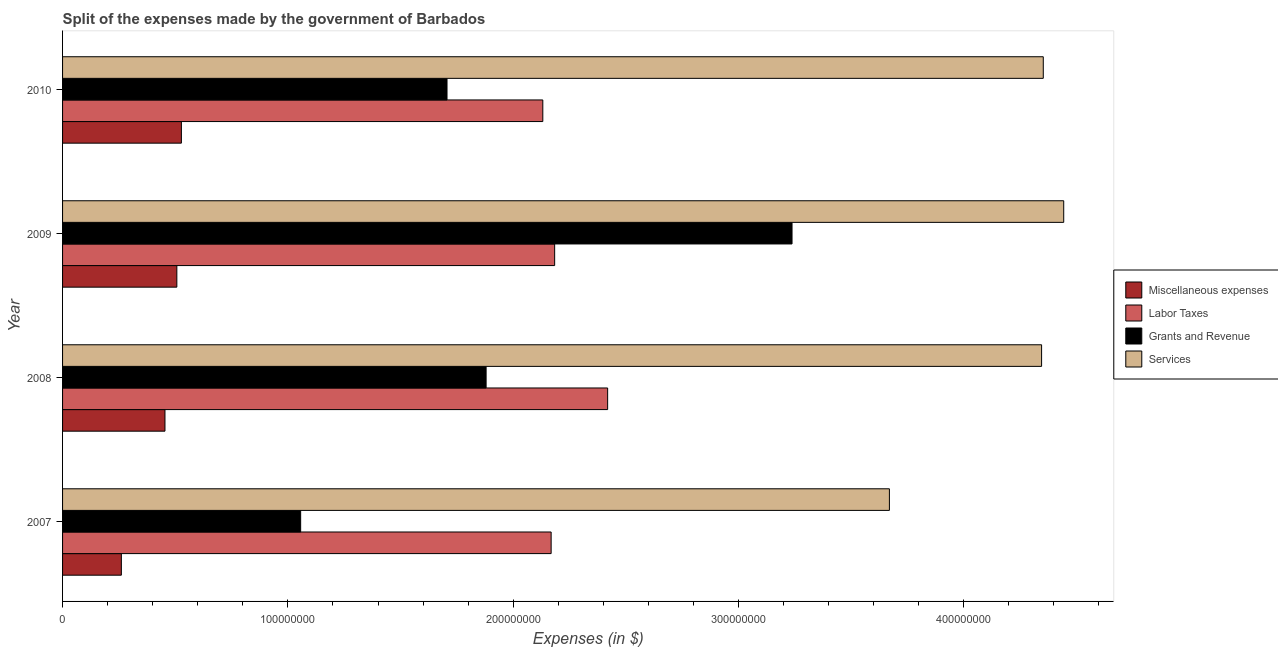How many different coloured bars are there?
Your answer should be compact. 4. How many groups of bars are there?
Your answer should be compact. 4. Are the number of bars per tick equal to the number of legend labels?
Make the answer very short. Yes. Are the number of bars on each tick of the Y-axis equal?
Give a very brief answer. Yes. How many bars are there on the 3rd tick from the top?
Offer a terse response. 4. In how many cases, is the number of bars for a given year not equal to the number of legend labels?
Provide a short and direct response. 0. What is the amount spent on services in 2009?
Your answer should be very brief. 4.44e+08. Across all years, what is the maximum amount spent on miscellaneous expenses?
Your answer should be very brief. 5.27e+07. Across all years, what is the minimum amount spent on services?
Give a very brief answer. 3.67e+08. In which year was the amount spent on labor taxes minimum?
Keep it short and to the point. 2010. What is the total amount spent on labor taxes in the graph?
Keep it short and to the point. 8.90e+08. What is the difference between the amount spent on services in 2007 and that in 2008?
Provide a succinct answer. -6.75e+07. What is the difference between the amount spent on miscellaneous expenses in 2010 and the amount spent on labor taxes in 2008?
Offer a very short reply. -1.89e+08. What is the average amount spent on miscellaneous expenses per year?
Your response must be concise. 4.38e+07. In the year 2009, what is the difference between the amount spent on miscellaneous expenses and amount spent on services?
Give a very brief answer. -3.94e+08. In how many years, is the amount spent on miscellaneous expenses greater than 260000000 $?
Provide a succinct answer. 0. What is the ratio of the amount spent on miscellaneous expenses in 2008 to that in 2010?
Your response must be concise. 0.86. Is the amount spent on grants and revenue in 2007 less than that in 2010?
Provide a succinct answer. Yes. What is the difference between the highest and the second highest amount spent on grants and revenue?
Provide a succinct answer. 1.36e+08. What is the difference between the highest and the lowest amount spent on services?
Your answer should be very brief. 7.74e+07. What does the 4th bar from the top in 2009 represents?
Offer a terse response. Miscellaneous expenses. What does the 2nd bar from the bottom in 2007 represents?
Give a very brief answer. Labor Taxes. Is it the case that in every year, the sum of the amount spent on miscellaneous expenses and amount spent on labor taxes is greater than the amount spent on grants and revenue?
Offer a very short reply. No. How many years are there in the graph?
Make the answer very short. 4. Are the values on the major ticks of X-axis written in scientific E-notation?
Your answer should be compact. No. Does the graph contain any zero values?
Your answer should be very brief. No. Where does the legend appear in the graph?
Ensure brevity in your answer.  Center right. How many legend labels are there?
Your response must be concise. 4. How are the legend labels stacked?
Make the answer very short. Vertical. What is the title of the graph?
Give a very brief answer. Split of the expenses made by the government of Barbados. What is the label or title of the X-axis?
Provide a succinct answer. Expenses (in $). What is the Expenses (in $) of Miscellaneous expenses in 2007?
Your answer should be compact. 2.61e+07. What is the Expenses (in $) of Labor Taxes in 2007?
Give a very brief answer. 2.17e+08. What is the Expenses (in $) of Grants and Revenue in 2007?
Keep it short and to the point. 1.06e+08. What is the Expenses (in $) of Services in 2007?
Your answer should be very brief. 3.67e+08. What is the Expenses (in $) of Miscellaneous expenses in 2008?
Ensure brevity in your answer.  4.55e+07. What is the Expenses (in $) of Labor Taxes in 2008?
Provide a succinct answer. 2.42e+08. What is the Expenses (in $) in Grants and Revenue in 2008?
Ensure brevity in your answer.  1.88e+08. What is the Expenses (in $) of Services in 2008?
Make the answer very short. 4.35e+08. What is the Expenses (in $) in Miscellaneous expenses in 2009?
Give a very brief answer. 5.07e+07. What is the Expenses (in $) of Labor Taxes in 2009?
Your answer should be compact. 2.18e+08. What is the Expenses (in $) in Grants and Revenue in 2009?
Your response must be concise. 3.24e+08. What is the Expenses (in $) in Services in 2009?
Offer a terse response. 4.44e+08. What is the Expenses (in $) in Miscellaneous expenses in 2010?
Your answer should be compact. 5.27e+07. What is the Expenses (in $) of Labor Taxes in 2010?
Your response must be concise. 2.13e+08. What is the Expenses (in $) in Grants and Revenue in 2010?
Your answer should be compact. 1.71e+08. What is the Expenses (in $) of Services in 2010?
Give a very brief answer. 4.35e+08. Across all years, what is the maximum Expenses (in $) in Miscellaneous expenses?
Keep it short and to the point. 5.27e+07. Across all years, what is the maximum Expenses (in $) in Labor Taxes?
Offer a terse response. 2.42e+08. Across all years, what is the maximum Expenses (in $) of Grants and Revenue?
Offer a terse response. 3.24e+08. Across all years, what is the maximum Expenses (in $) of Services?
Your answer should be compact. 4.44e+08. Across all years, what is the minimum Expenses (in $) in Miscellaneous expenses?
Your answer should be very brief. 2.61e+07. Across all years, what is the minimum Expenses (in $) in Labor Taxes?
Your answer should be very brief. 2.13e+08. Across all years, what is the minimum Expenses (in $) of Grants and Revenue?
Give a very brief answer. 1.06e+08. Across all years, what is the minimum Expenses (in $) in Services?
Your answer should be compact. 3.67e+08. What is the total Expenses (in $) of Miscellaneous expenses in the graph?
Your response must be concise. 1.75e+08. What is the total Expenses (in $) in Labor Taxes in the graph?
Ensure brevity in your answer.  8.90e+08. What is the total Expenses (in $) of Grants and Revenue in the graph?
Offer a terse response. 7.88e+08. What is the total Expenses (in $) in Services in the graph?
Keep it short and to the point. 1.68e+09. What is the difference between the Expenses (in $) in Miscellaneous expenses in 2007 and that in 2008?
Provide a short and direct response. -1.94e+07. What is the difference between the Expenses (in $) in Labor Taxes in 2007 and that in 2008?
Ensure brevity in your answer.  -2.51e+07. What is the difference between the Expenses (in $) of Grants and Revenue in 2007 and that in 2008?
Your response must be concise. -8.23e+07. What is the difference between the Expenses (in $) of Services in 2007 and that in 2008?
Your response must be concise. -6.75e+07. What is the difference between the Expenses (in $) of Miscellaneous expenses in 2007 and that in 2009?
Provide a short and direct response. -2.46e+07. What is the difference between the Expenses (in $) in Labor Taxes in 2007 and that in 2009?
Provide a succinct answer. -1.56e+06. What is the difference between the Expenses (in $) of Grants and Revenue in 2007 and that in 2009?
Provide a short and direct response. -2.18e+08. What is the difference between the Expenses (in $) in Services in 2007 and that in 2009?
Ensure brevity in your answer.  -7.74e+07. What is the difference between the Expenses (in $) in Miscellaneous expenses in 2007 and that in 2010?
Your response must be concise. -2.66e+07. What is the difference between the Expenses (in $) in Labor Taxes in 2007 and that in 2010?
Your answer should be compact. 3.69e+06. What is the difference between the Expenses (in $) in Grants and Revenue in 2007 and that in 2010?
Make the answer very short. -6.50e+07. What is the difference between the Expenses (in $) of Services in 2007 and that in 2010?
Your response must be concise. -6.83e+07. What is the difference between the Expenses (in $) in Miscellaneous expenses in 2008 and that in 2009?
Make the answer very short. -5.27e+06. What is the difference between the Expenses (in $) of Labor Taxes in 2008 and that in 2009?
Offer a terse response. 2.35e+07. What is the difference between the Expenses (in $) in Grants and Revenue in 2008 and that in 2009?
Your answer should be compact. -1.36e+08. What is the difference between the Expenses (in $) in Services in 2008 and that in 2009?
Your answer should be very brief. -9.82e+06. What is the difference between the Expenses (in $) of Miscellaneous expenses in 2008 and that in 2010?
Make the answer very short. -7.29e+06. What is the difference between the Expenses (in $) in Labor Taxes in 2008 and that in 2010?
Keep it short and to the point. 2.88e+07. What is the difference between the Expenses (in $) of Grants and Revenue in 2008 and that in 2010?
Your answer should be compact. 1.73e+07. What is the difference between the Expenses (in $) of Services in 2008 and that in 2010?
Provide a short and direct response. -7.51e+05. What is the difference between the Expenses (in $) of Miscellaneous expenses in 2009 and that in 2010?
Keep it short and to the point. -2.02e+06. What is the difference between the Expenses (in $) of Labor Taxes in 2009 and that in 2010?
Provide a short and direct response. 5.25e+06. What is the difference between the Expenses (in $) of Grants and Revenue in 2009 and that in 2010?
Your answer should be compact. 1.53e+08. What is the difference between the Expenses (in $) in Services in 2009 and that in 2010?
Provide a succinct answer. 9.07e+06. What is the difference between the Expenses (in $) in Miscellaneous expenses in 2007 and the Expenses (in $) in Labor Taxes in 2008?
Offer a very short reply. -2.16e+08. What is the difference between the Expenses (in $) of Miscellaneous expenses in 2007 and the Expenses (in $) of Grants and Revenue in 2008?
Give a very brief answer. -1.62e+08. What is the difference between the Expenses (in $) of Miscellaneous expenses in 2007 and the Expenses (in $) of Services in 2008?
Offer a terse response. -4.08e+08. What is the difference between the Expenses (in $) in Labor Taxes in 2007 and the Expenses (in $) in Grants and Revenue in 2008?
Provide a short and direct response. 2.89e+07. What is the difference between the Expenses (in $) in Labor Taxes in 2007 and the Expenses (in $) in Services in 2008?
Ensure brevity in your answer.  -2.18e+08. What is the difference between the Expenses (in $) in Grants and Revenue in 2007 and the Expenses (in $) in Services in 2008?
Your answer should be compact. -3.29e+08. What is the difference between the Expenses (in $) in Miscellaneous expenses in 2007 and the Expenses (in $) in Labor Taxes in 2009?
Keep it short and to the point. -1.92e+08. What is the difference between the Expenses (in $) of Miscellaneous expenses in 2007 and the Expenses (in $) of Grants and Revenue in 2009?
Provide a succinct answer. -2.98e+08. What is the difference between the Expenses (in $) of Miscellaneous expenses in 2007 and the Expenses (in $) of Services in 2009?
Your answer should be compact. -4.18e+08. What is the difference between the Expenses (in $) of Labor Taxes in 2007 and the Expenses (in $) of Grants and Revenue in 2009?
Provide a short and direct response. -1.07e+08. What is the difference between the Expenses (in $) of Labor Taxes in 2007 and the Expenses (in $) of Services in 2009?
Your response must be concise. -2.28e+08. What is the difference between the Expenses (in $) in Grants and Revenue in 2007 and the Expenses (in $) in Services in 2009?
Ensure brevity in your answer.  -3.39e+08. What is the difference between the Expenses (in $) in Miscellaneous expenses in 2007 and the Expenses (in $) in Labor Taxes in 2010?
Make the answer very short. -1.87e+08. What is the difference between the Expenses (in $) of Miscellaneous expenses in 2007 and the Expenses (in $) of Grants and Revenue in 2010?
Offer a very short reply. -1.45e+08. What is the difference between the Expenses (in $) in Miscellaneous expenses in 2007 and the Expenses (in $) in Services in 2010?
Offer a very short reply. -4.09e+08. What is the difference between the Expenses (in $) of Labor Taxes in 2007 and the Expenses (in $) of Grants and Revenue in 2010?
Make the answer very short. 4.62e+07. What is the difference between the Expenses (in $) of Labor Taxes in 2007 and the Expenses (in $) of Services in 2010?
Ensure brevity in your answer.  -2.18e+08. What is the difference between the Expenses (in $) in Grants and Revenue in 2007 and the Expenses (in $) in Services in 2010?
Your answer should be compact. -3.30e+08. What is the difference between the Expenses (in $) in Miscellaneous expenses in 2008 and the Expenses (in $) in Labor Taxes in 2009?
Make the answer very short. -1.73e+08. What is the difference between the Expenses (in $) of Miscellaneous expenses in 2008 and the Expenses (in $) of Grants and Revenue in 2009?
Make the answer very short. -2.78e+08. What is the difference between the Expenses (in $) of Miscellaneous expenses in 2008 and the Expenses (in $) of Services in 2009?
Your answer should be compact. -3.99e+08. What is the difference between the Expenses (in $) in Labor Taxes in 2008 and the Expenses (in $) in Grants and Revenue in 2009?
Provide a short and direct response. -8.18e+07. What is the difference between the Expenses (in $) of Labor Taxes in 2008 and the Expenses (in $) of Services in 2009?
Provide a succinct answer. -2.02e+08. What is the difference between the Expenses (in $) in Grants and Revenue in 2008 and the Expenses (in $) in Services in 2009?
Keep it short and to the point. -2.56e+08. What is the difference between the Expenses (in $) in Miscellaneous expenses in 2008 and the Expenses (in $) in Labor Taxes in 2010?
Make the answer very short. -1.68e+08. What is the difference between the Expenses (in $) in Miscellaneous expenses in 2008 and the Expenses (in $) in Grants and Revenue in 2010?
Offer a very short reply. -1.25e+08. What is the difference between the Expenses (in $) in Miscellaneous expenses in 2008 and the Expenses (in $) in Services in 2010?
Provide a short and direct response. -3.90e+08. What is the difference between the Expenses (in $) in Labor Taxes in 2008 and the Expenses (in $) in Grants and Revenue in 2010?
Ensure brevity in your answer.  7.13e+07. What is the difference between the Expenses (in $) of Labor Taxes in 2008 and the Expenses (in $) of Services in 2010?
Provide a short and direct response. -1.93e+08. What is the difference between the Expenses (in $) in Grants and Revenue in 2008 and the Expenses (in $) in Services in 2010?
Make the answer very short. -2.47e+08. What is the difference between the Expenses (in $) in Miscellaneous expenses in 2009 and the Expenses (in $) in Labor Taxes in 2010?
Make the answer very short. -1.62e+08. What is the difference between the Expenses (in $) of Miscellaneous expenses in 2009 and the Expenses (in $) of Grants and Revenue in 2010?
Provide a succinct answer. -1.20e+08. What is the difference between the Expenses (in $) of Miscellaneous expenses in 2009 and the Expenses (in $) of Services in 2010?
Provide a succinct answer. -3.85e+08. What is the difference between the Expenses (in $) of Labor Taxes in 2009 and the Expenses (in $) of Grants and Revenue in 2010?
Offer a terse response. 4.78e+07. What is the difference between the Expenses (in $) in Labor Taxes in 2009 and the Expenses (in $) in Services in 2010?
Ensure brevity in your answer.  -2.17e+08. What is the difference between the Expenses (in $) of Grants and Revenue in 2009 and the Expenses (in $) of Services in 2010?
Your response must be concise. -1.12e+08. What is the average Expenses (in $) in Miscellaneous expenses per year?
Offer a very short reply. 4.38e+07. What is the average Expenses (in $) in Labor Taxes per year?
Make the answer very short. 2.23e+08. What is the average Expenses (in $) of Grants and Revenue per year?
Provide a succinct answer. 1.97e+08. What is the average Expenses (in $) in Services per year?
Make the answer very short. 4.20e+08. In the year 2007, what is the difference between the Expenses (in $) of Miscellaneous expenses and Expenses (in $) of Labor Taxes?
Your response must be concise. -1.91e+08. In the year 2007, what is the difference between the Expenses (in $) in Miscellaneous expenses and Expenses (in $) in Grants and Revenue?
Your response must be concise. -7.96e+07. In the year 2007, what is the difference between the Expenses (in $) in Miscellaneous expenses and Expenses (in $) in Services?
Keep it short and to the point. -3.41e+08. In the year 2007, what is the difference between the Expenses (in $) in Labor Taxes and Expenses (in $) in Grants and Revenue?
Keep it short and to the point. 1.11e+08. In the year 2007, what is the difference between the Expenses (in $) of Labor Taxes and Expenses (in $) of Services?
Your response must be concise. -1.50e+08. In the year 2007, what is the difference between the Expenses (in $) of Grants and Revenue and Expenses (in $) of Services?
Ensure brevity in your answer.  -2.61e+08. In the year 2008, what is the difference between the Expenses (in $) in Miscellaneous expenses and Expenses (in $) in Labor Taxes?
Keep it short and to the point. -1.96e+08. In the year 2008, what is the difference between the Expenses (in $) in Miscellaneous expenses and Expenses (in $) in Grants and Revenue?
Provide a short and direct response. -1.43e+08. In the year 2008, what is the difference between the Expenses (in $) in Miscellaneous expenses and Expenses (in $) in Services?
Give a very brief answer. -3.89e+08. In the year 2008, what is the difference between the Expenses (in $) of Labor Taxes and Expenses (in $) of Grants and Revenue?
Your answer should be very brief. 5.39e+07. In the year 2008, what is the difference between the Expenses (in $) of Labor Taxes and Expenses (in $) of Services?
Give a very brief answer. -1.93e+08. In the year 2008, what is the difference between the Expenses (in $) of Grants and Revenue and Expenses (in $) of Services?
Ensure brevity in your answer.  -2.47e+08. In the year 2009, what is the difference between the Expenses (in $) in Miscellaneous expenses and Expenses (in $) in Labor Taxes?
Offer a very short reply. -1.68e+08. In the year 2009, what is the difference between the Expenses (in $) of Miscellaneous expenses and Expenses (in $) of Grants and Revenue?
Provide a short and direct response. -2.73e+08. In the year 2009, what is the difference between the Expenses (in $) of Miscellaneous expenses and Expenses (in $) of Services?
Your answer should be compact. -3.94e+08. In the year 2009, what is the difference between the Expenses (in $) in Labor Taxes and Expenses (in $) in Grants and Revenue?
Your answer should be compact. -1.05e+08. In the year 2009, what is the difference between the Expenses (in $) in Labor Taxes and Expenses (in $) in Services?
Offer a very short reply. -2.26e+08. In the year 2009, what is the difference between the Expenses (in $) in Grants and Revenue and Expenses (in $) in Services?
Ensure brevity in your answer.  -1.21e+08. In the year 2010, what is the difference between the Expenses (in $) in Miscellaneous expenses and Expenses (in $) in Labor Taxes?
Provide a short and direct response. -1.60e+08. In the year 2010, what is the difference between the Expenses (in $) in Miscellaneous expenses and Expenses (in $) in Grants and Revenue?
Your answer should be compact. -1.18e+08. In the year 2010, what is the difference between the Expenses (in $) in Miscellaneous expenses and Expenses (in $) in Services?
Offer a very short reply. -3.83e+08. In the year 2010, what is the difference between the Expenses (in $) of Labor Taxes and Expenses (in $) of Grants and Revenue?
Make the answer very short. 4.25e+07. In the year 2010, what is the difference between the Expenses (in $) of Labor Taxes and Expenses (in $) of Services?
Your answer should be very brief. -2.22e+08. In the year 2010, what is the difference between the Expenses (in $) of Grants and Revenue and Expenses (in $) of Services?
Give a very brief answer. -2.65e+08. What is the ratio of the Expenses (in $) of Miscellaneous expenses in 2007 to that in 2008?
Your answer should be compact. 0.57. What is the ratio of the Expenses (in $) of Labor Taxes in 2007 to that in 2008?
Your answer should be very brief. 0.9. What is the ratio of the Expenses (in $) of Grants and Revenue in 2007 to that in 2008?
Give a very brief answer. 0.56. What is the ratio of the Expenses (in $) of Services in 2007 to that in 2008?
Make the answer very short. 0.84. What is the ratio of the Expenses (in $) of Miscellaneous expenses in 2007 to that in 2009?
Offer a terse response. 0.51. What is the ratio of the Expenses (in $) of Grants and Revenue in 2007 to that in 2009?
Keep it short and to the point. 0.33. What is the ratio of the Expenses (in $) in Services in 2007 to that in 2009?
Your response must be concise. 0.83. What is the ratio of the Expenses (in $) in Miscellaneous expenses in 2007 to that in 2010?
Give a very brief answer. 0.49. What is the ratio of the Expenses (in $) of Labor Taxes in 2007 to that in 2010?
Offer a terse response. 1.02. What is the ratio of the Expenses (in $) in Grants and Revenue in 2007 to that in 2010?
Your response must be concise. 0.62. What is the ratio of the Expenses (in $) in Services in 2007 to that in 2010?
Offer a very short reply. 0.84. What is the ratio of the Expenses (in $) in Miscellaneous expenses in 2008 to that in 2009?
Offer a very short reply. 0.9. What is the ratio of the Expenses (in $) of Labor Taxes in 2008 to that in 2009?
Keep it short and to the point. 1.11. What is the ratio of the Expenses (in $) in Grants and Revenue in 2008 to that in 2009?
Provide a short and direct response. 0.58. What is the ratio of the Expenses (in $) of Services in 2008 to that in 2009?
Keep it short and to the point. 0.98. What is the ratio of the Expenses (in $) in Miscellaneous expenses in 2008 to that in 2010?
Provide a succinct answer. 0.86. What is the ratio of the Expenses (in $) of Labor Taxes in 2008 to that in 2010?
Offer a terse response. 1.14. What is the ratio of the Expenses (in $) of Grants and Revenue in 2008 to that in 2010?
Make the answer very short. 1.1. What is the ratio of the Expenses (in $) in Services in 2008 to that in 2010?
Offer a terse response. 1. What is the ratio of the Expenses (in $) in Miscellaneous expenses in 2009 to that in 2010?
Provide a short and direct response. 0.96. What is the ratio of the Expenses (in $) of Labor Taxes in 2009 to that in 2010?
Provide a short and direct response. 1.02. What is the ratio of the Expenses (in $) in Grants and Revenue in 2009 to that in 2010?
Provide a succinct answer. 1.9. What is the ratio of the Expenses (in $) of Services in 2009 to that in 2010?
Offer a very short reply. 1.02. What is the difference between the highest and the second highest Expenses (in $) of Miscellaneous expenses?
Provide a short and direct response. 2.02e+06. What is the difference between the highest and the second highest Expenses (in $) of Labor Taxes?
Ensure brevity in your answer.  2.35e+07. What is the difference between the highest and the second highest Expenses (in $) in Grants and Revenue?
Your answer should be compact. 1.36e+08. What is the difference between the highest and the second highest Expenses (in $) in Services?
Keep it short and to the point. 9.07e+06. What is the difference between the highest and the lowest Expenses (in $) of Miscellaneous expenses?
Offer a very short reply. 2.66e+07. What is the difference between the highest and the lowest Expenses (in $) of Labor Taxes?
Offer a very short reply. 2.88e+07. What is the difference between the highest and the lowest Expenses (in $) in Grants and Revenue?
Make the answer very short. 2.18e+08. What is the difference between the highest and the lowest Expenses (in $) in Services?
Provide a succinct answer. 7.74e+07. 